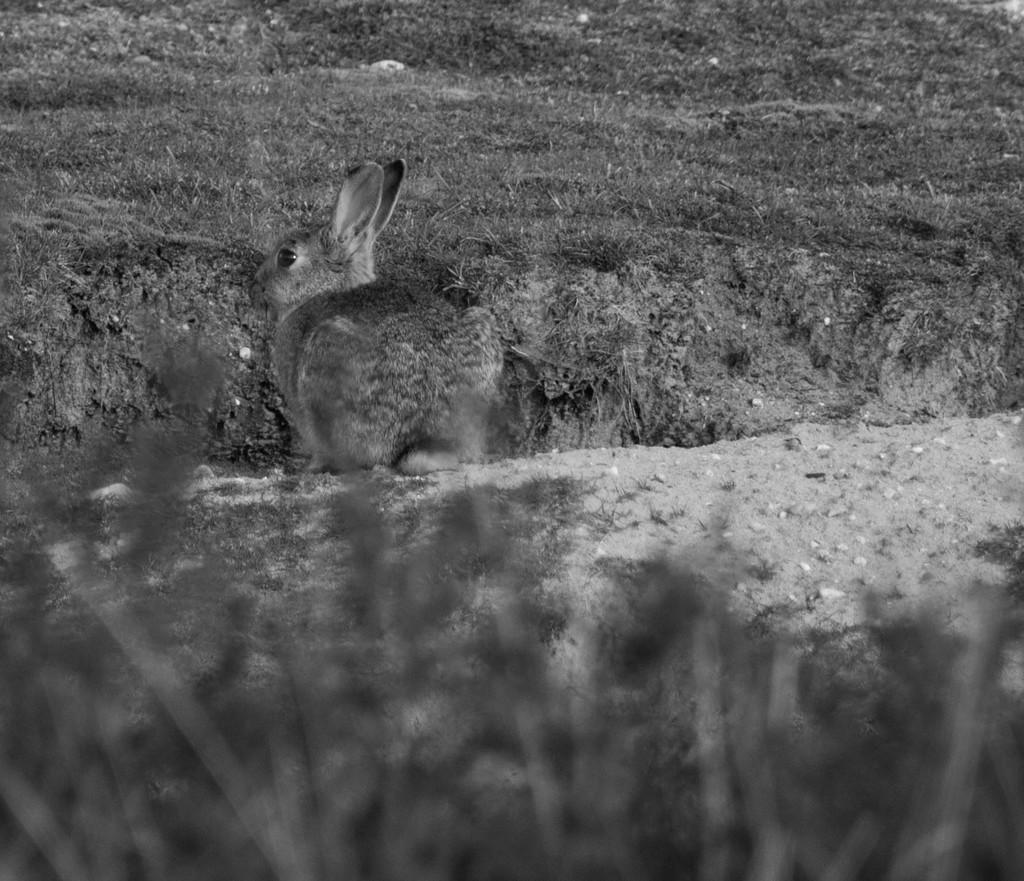What type of vegetation can be seen in the image? There is grass in the image. What animal is present in the image? There is a rabbit in the image. What type of terrain is visible towards the right side of the image? There is sand towards the right side of the image. What other objects can be seen in the image? There are stones in the image. What else is present at the bottom of the image? There are plants towards the bottom of the image. What type of industry is depicted in the image? There is no industry present in the image; it features grass, a rabbit, sand, stones, and plants. How does the front of the image look like? The term "front" is not applicable to the image, as it is a two-dimensional representation. 